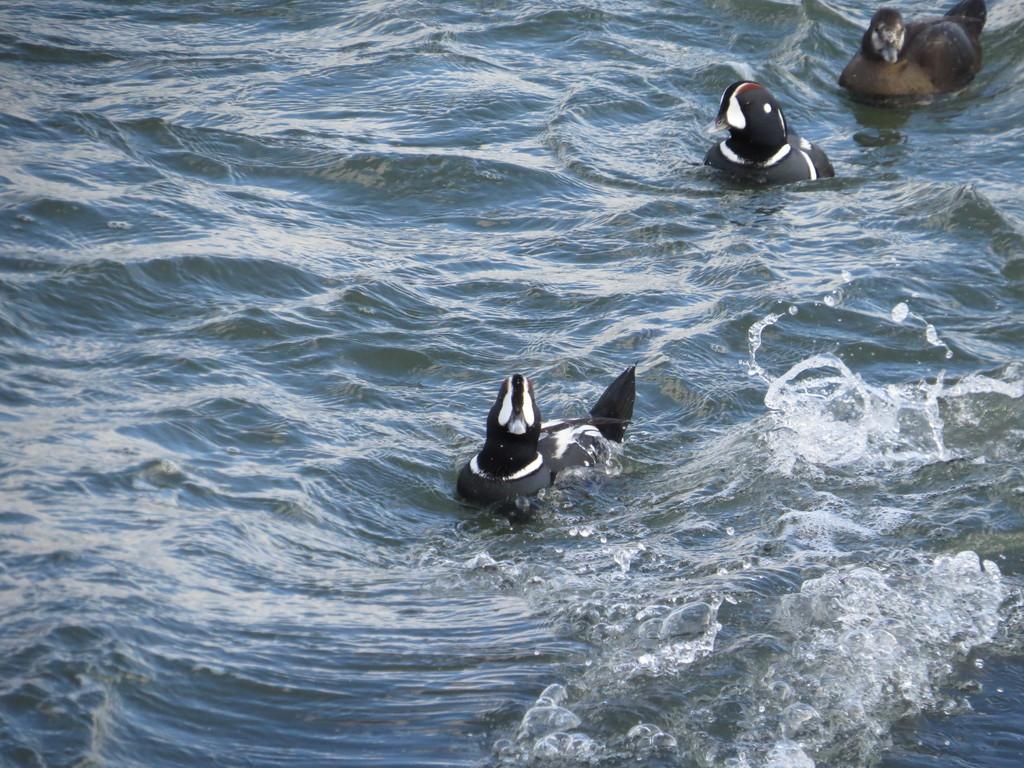Could you give a brief overview of what you see in this image? In this image I can see the water and on the surface of the water I can see three aquatic animals which are white and black in color. 